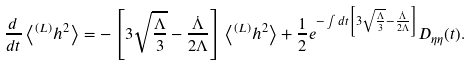<formula> <loc_0><loc_0><loc_500><loc_500>\frac { d } { d t } \left < ^ { ( L ) } h ^ { 2 } \right > = - \left [ 3 \sqrt { \frac { \Lambda } { 3 } } - \frac { \dot { \Lambda } } { 2 \Lambda } \right ] \left < ^ { ( L ) } h ^ { 2 } \right > + \frac { 1 } { 2 } e ^ { - \int d t \left [ 3 \sqrt { \frac { \Lambda } { 3 } } - \frac { \dot { \Lambda } } { 2 \Lambda } \right ] } D _ { \eta \eta } ( t ) .</formula> 